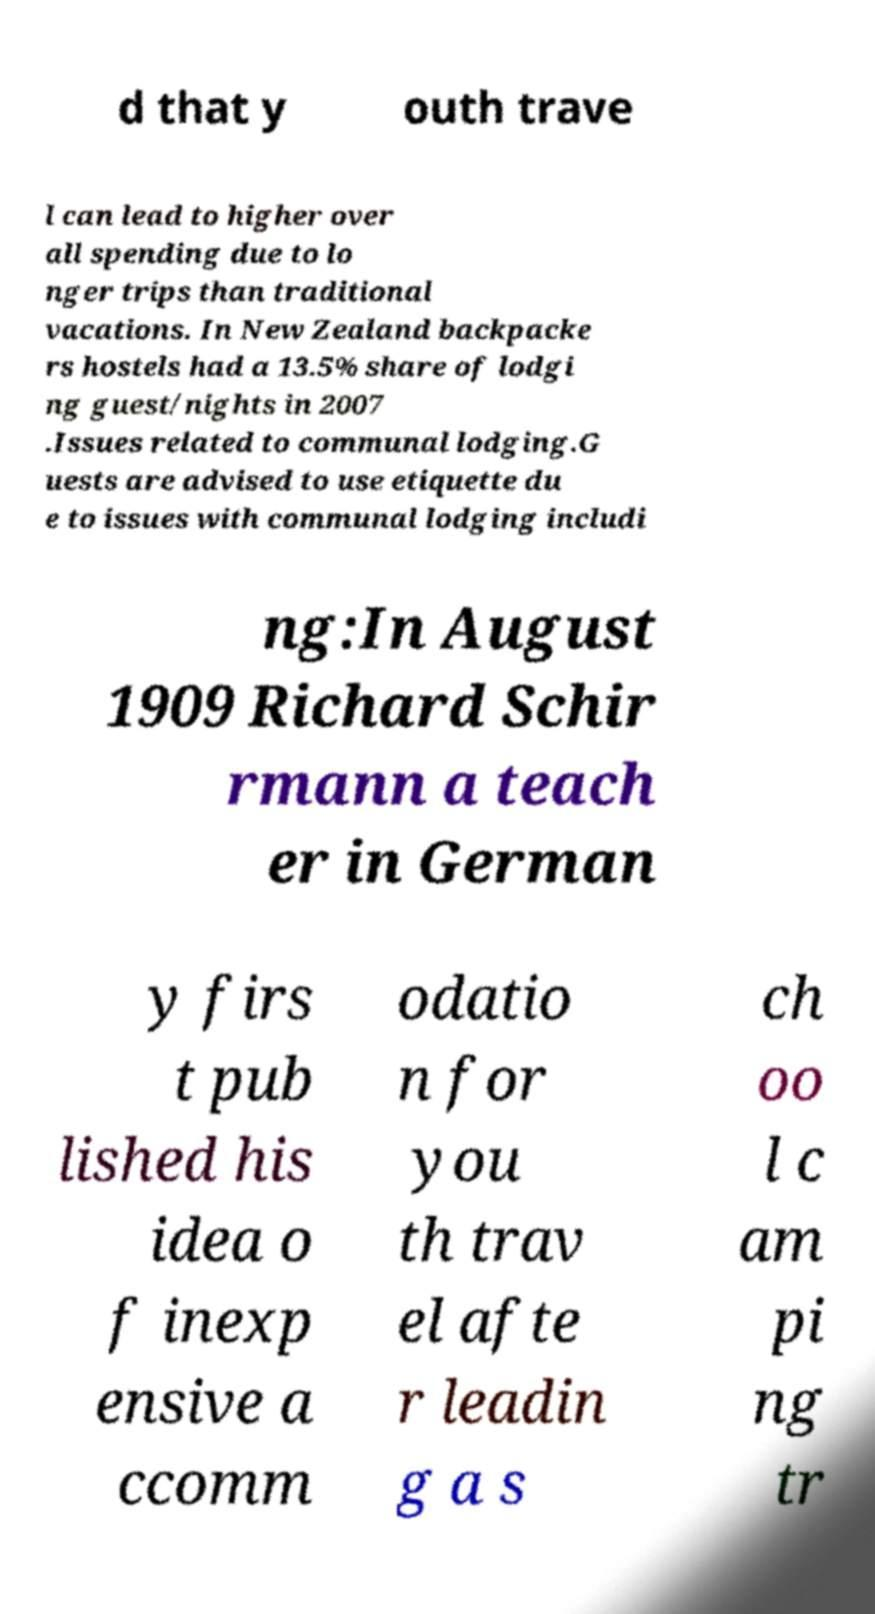Can you accurately transcribe the text from the provided image for me? d that y outh trave l can lead to higher over all spending due to lo nger trips than traditional vacations. In New Zealand backpacke rs hostels had a 13.5% share of lodgi ng guest/nights in 2007 .Issues related to communal lodging.G uests are advised to use etiquette du e to issues with communal lodging includi ng:In August 1909 Richard Schir rmann a teach er in German y firs t pub lished his idea o f inexp ensive a ccomm odatio n for you th trav el afte r leadin g a s ch oo l c am pi ng tr 